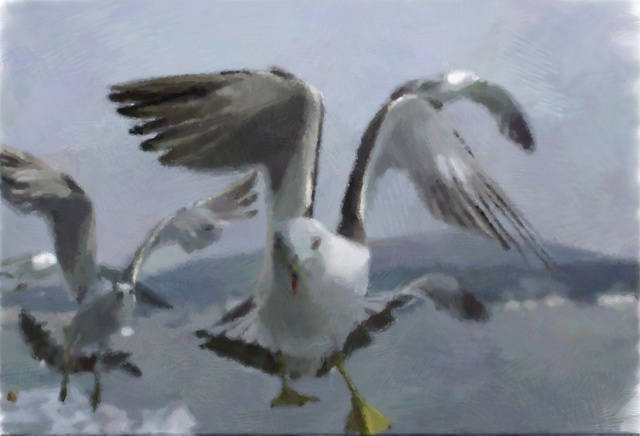Describe the objects in this image and their specific colors. I can see bird in white, gray, darkgray, and black tones and bird in white, gray, darkgray, and black tones in this image. 